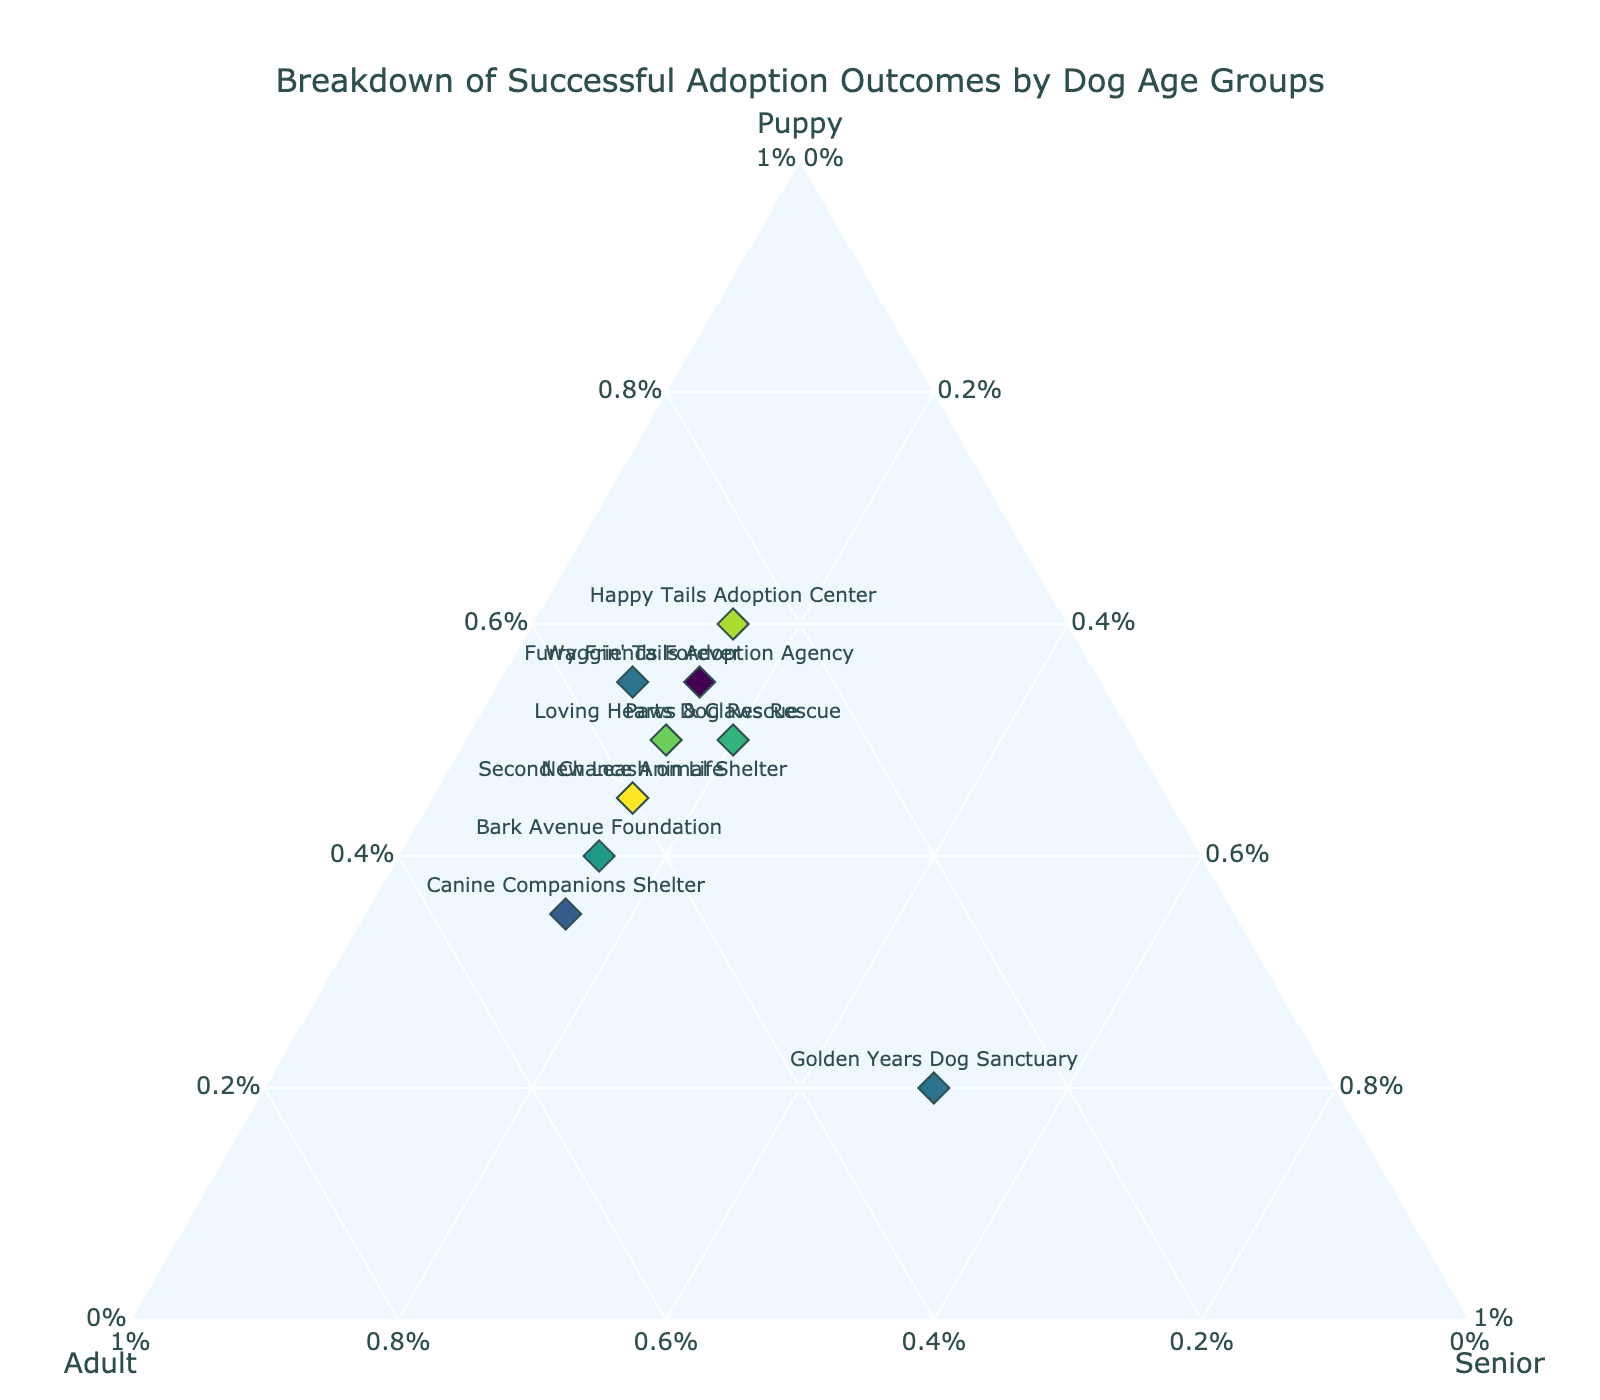What's the title of the figure? The title is displayed at the top of the figure in a larger font and centered. It reads "Breakdown of Successful Adoption Outcomes by Dog Age Groups."
Answer: Breakdown of Successful Adoption Outcomes by Dog Age Groups How many dog shelters are shown in the figure? Each dog shelter is represented by a diamond marker. By counting these markers, we determine that there are 10 dog shelters in the figure.
Answer: 10 Which dog shelter shows the highest adoption rate for senior dogs? We look for the marker closest to the Senior axis at the bottom of the ternary plot. The label for this marker points to "Golden Years Dog Sanctuary" with 50% senior adoptions.
Answer: Golden Years Dog Sanctuary Which two dog shelters have the same adoption rates for adult and senior dogs? By examining the ternary plot, we find two dog shelters with the same positioning for the adult (45%) and senior (15%) axes. These are "Second Chance Animal Shelter" and "New Leash on Life".
Answer: Second Chance Animal Shelter and New Leash on Life What is the average adoption rate for adult dogs across all shelters? Add the adoption rates for adults from all shelters (0.3 + 0.25 + 0.4 + 0.35 + 0.45 + 0.35 + 0.5 + 0.3 + 0.4 + 0.3) and divide by the number of shelters (10). Sum is 3.6; divide by 10 for the average.
Answer: 0.36 Which dog shelter has the most balanced adoption rates among all age groups? A shelter with balanced adoption rates will be equidistant from all three axes in the ternary plot. "Paws & Claws Rescue" with rates (0.5, 0.3, 0.2) is the closest.
Answer: Paws & Claws Rescue How many shelters have a higher adoption rate for puppies than adults? Compare the adoption rates for puppies and adults for each shelter. Count the shelters where the puppy rate is higher: "Paws & Claws Rescue", "Happy Tails Adoption Center", "Furry Friends Forever", "Loving Hearts Dog Rescue", "Waggin' Tails Adoption Agency".
Answer: 5 If the adoption rate for adult dogs is above 0.4, which shelters are included? Look for shelters with adult adoption rates above 0.4. These are "Bark Avenue Foundation" and "Canine Companions Shelter".
Answer: Bark Avenue Foundation and Canine Companions Shelter Which shelter has the lowest adoption rate for puppies? The shelter closest to the Adult-Senior line at the bottom of the ternary plot has the lowest puppy adoption rate. This is "Golden Years Dog Sanctuary" with a 20% puppy adoption rate.
Answer: Golden Years Dog Sanctuary What percentage of dog shelters have identical senior adoption rates? Identify shelters with identical senior adoption rates. All shelters except "Golden Years Dog Sanctuary" have a senior adoption rate of 15%, totaling 9 shelters. Divide by total shelters, and multiply by 100 for percentage.
Answer: 90% 